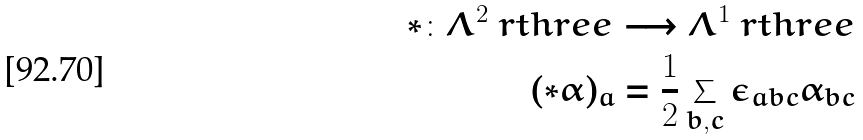<formula> <loc_0><loc_0><loc_500><loc_500>\ast \colon \Lambda ^ { 2 } \ r t h r e e \longrightarrow \Lambda ^ { 1 } \ r t h r e e \\ ( \ast \alpha ) _ { a } = \frac { 1 } { 2 } \sum _ { b , c } \epsilon _ { a b c } \alpha _ { b c }</formula> 